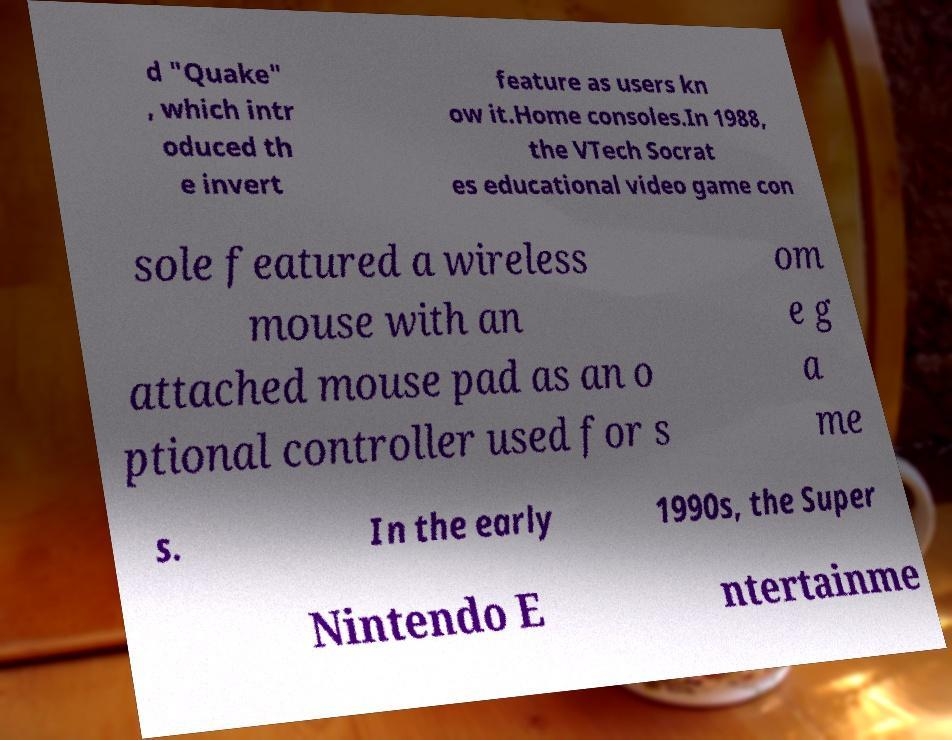Can you read and provide the text displayed in the image?This photo seems to have some interesting text. Can you extract and type it out for me? d "Quake" , which intr oduced th e invert feature as users kn ow it.Home consoles.In 1988, the VTech Socrat es educational video game con sole featured a wireless mouse with an attached mouse pad as an o ptional controller used for s om e g a me s. In the early 1990s, the Super Nintendo E ntertainme 